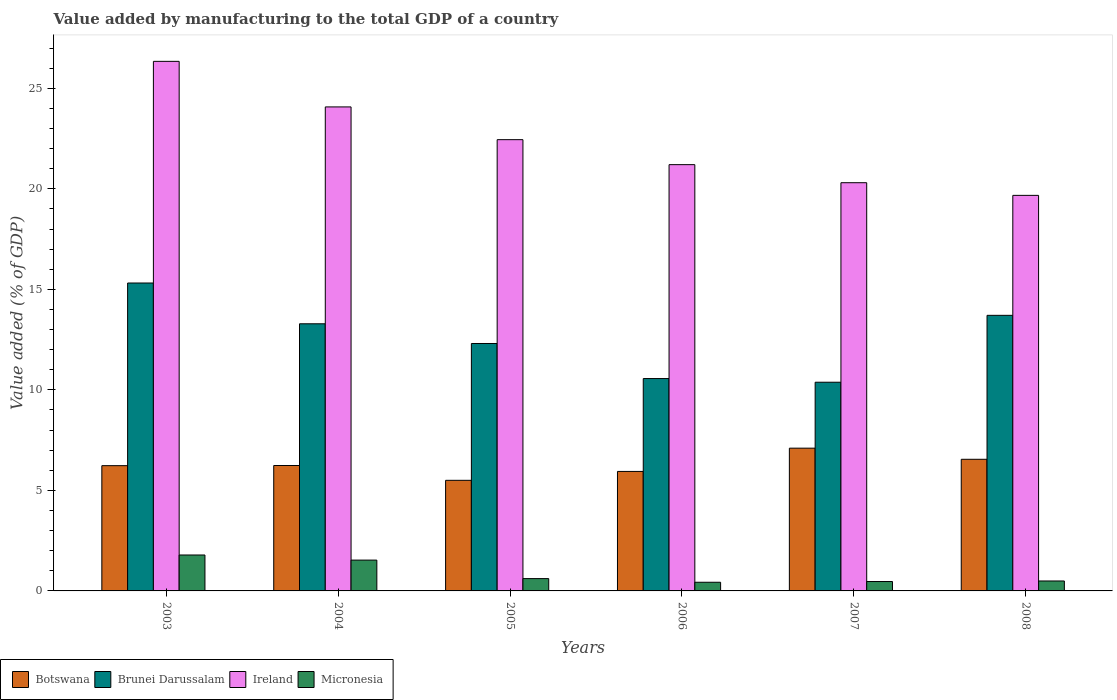How many different coloured bars are there?
Offer a very short reply. 4. What is the value added by manufacturing to the total GDP in Micronesia in 2007?
Your response must be concise. 0.47. Across all years, what is the maximum value added by manufacturing to the total GDP in Ireland?
Provide a short and direct response. 26.34. Across all years, what is the minimum value added by manufacturing to the total GDP in Ireland?
Provide a succinct answer. 19.68. In which year was the value added by manufacturing to the total GDP in Botswana maximum?
Offer a terse response. 2007. What is the total value added by manufacturing to the total GDP in Micronesia in the graph?
Offer a very short reply. 5.33. What is the difference between the value added by manufacturing to the total GDP in Brunei Darussalam in 2003 and that in 2004?
Ensure brevity in your answer.  2.03. What is the difference between the value added by manufacturing to the total GDP in Ireland in 2008 and the value added by manufacturing to the total GDP in Micronesia in 2003?
Your answer should be very brief. 17.89. What is the average value added by manufacturing to the total GDP in Botswana per year?
Provide a succinct answer. 6.26. In the year 2008, what is the difference between the value added by manufacturing to the total GDP in Ireland and value added by manufacturing to the total GDP in Brunei Darussalam?
Make the answer very short. 5.97. What is the ratio of the value added by manufacturing to the total GDP in Brunei Darussalam in 2005 to that in 2008?
Your answer should be compact. 0.9. Is the value added by manufacturing to the total GDP in Botswana in 2005 less than that in 2008?
Keep it short and to the point. Yes. What is the difference between the highest and the second highest value added by manufacturing to the total GDP in Brunei Darussalam?
Offer a terse response. 1.61. What is the difference between the highest and the lowest value added by manufacturing to the total GDP in Brunei Darussalam?
Offer a very short reply. 4.93. Is the sum of the value added by manufacturing to the total GDP in Botswana in 2005 and 2007 greater than the maximum value added by manufacturing to the total GDP in Brunei Darussalam across all years?
Ensure brevity in your answer.  No. Is it the case that in every year, the sum of the value added by manufacturing to the total GDP in Brunei Darussalam and value added by manufacturing to the total GDP in Micronesia is greater than the sum of value added by manufacturing to the total GDP in Ireland and value added by manufacturing to the total GDP in Botswana?
Make the answer very short. No. What does the 2nd bar from the left in 2007 represents?
Offer a terse response. Brunei Darussalam. What does the 2nd bar from the right in 2005 represents?
Make the answer very short. Ireland. Is it the case that in every year, the sum of the value added by manufacturing to the total GDP in Micronesia and value added by manufacturing to the total GDP in Brunei Darussalam is greater than the value added by manufacturing to the total GDP in Ireland?
Your response must be concise. No. How many years are there in the graph?
Ensure brevity in your answer.  6. What is the difference between two consecutive major ticks on the Y-axis?
Your answer should be very brief. 5. Are the values on the major ticks of Y-axis written in scientific E-notation?
Your response must be concise. No. Does the graph contain grids?
Give a very brief answer. No. Where does the legend appear in the graph?
Offer a very short reply. Bottom left. What is the title of the graph?
Give a very brief answer. Value added by manufacturing to the total GDP of a country. What is the label or title of the Y-axis?
Keep it short and to the point. Value added (% of GDP). What is the Value added (% of GDP) in Botswana in 2003?
Give a very brief answer. 6.23. What is the Value added (% of GDP) in Brunei Darussalam in 2003?
Give a very brief answer. 15.32. What is the Value added (% of GDP) in Ireland in 2003?
Offer a very short reply. 26.34. What is the Value added (% of GDP) of Micronesia in 2003?
Ensure brevity in your answer.  1.79. What is the Value added (% of GDP) of Botswana in 2004?
Provide a succinct answer. 6.24. What is the Value added (% of GDP) in Brunei Darussalam in 2004?
Offer a very short reply. 13.29. What is the Value added (% of GDP) in Ireland in 2004?
Your response must be concise. 24.07. What is the Value added (% of GDP) of Micronesia in 2004?
Give a very brief answer. 1.53. What is the Value added (% of GDP) of Botswana in 2005?
Keep it short and to the point. 5.5. What is the Value added (% of GDP) of Brunei Darussalam in 2005?
Give a very brief answer. 12.31. What is the Value added (% of GDP) in Ireland in 2005?
Provide a succinct answer. 22.45. What is the Value added (% of GDP) of Micronesia in 2005?
Give a very brief answer. 0.61. What is the Value added (% of GDP) of Botswana in 2006?
Offer a very short reply. 5.94. What is the Value added (% of GDP) in Brunei Darussalam in 2006?
Your answer should be very brief. 10.56. What is the Value added (% of GDP) of Ireland in 2006?
Keep it short and to the point. 21.2. What is the Value added (% of GDP) of Micronesia in 2006?
Keep it short and to the point. 0.43. What is the Value added (% of GDP) of Botswana in 2007?
Provide a short and direct response. 7.1. What is the Value added (% of GDP) of Brunei Darussalam in 2007?
Offer a terse response. 10.38. What is the Value added (% of GDP) of Ireland in 2007?
Make the answer very short. 20.31. What is the Value added (% of GDP) of Micronesia in 2007?
Give a very brief answer. 0.47. What is the Value added (% of GDP) of Botswana in 2008?
Your response must be concise. 6.55. What is the Value added (% of GDP) in Brunei Darussalam in 2008?
Your response must be concise. 13.71. What is the Value added (% of GDP) of Ireland in 2008?
Ensure brevity in your answer.  19.68. What is the Value added (% of GDP) in Micronesia in 2008?
Make the answer very short. 0.49. Across all years, what is the maximum Value added (% of GDP) of Botswana?
Provide a short and direct response. 7.1. Across all years, what is the maximum Value added (% of GDP) in Brunei Darussalam?
Offer a terse response. 15.32. Across all years, what is the maximum Value added (% of GDP) of Ireland?
Your answer should be compact. 26.34. Across all years, what is the maximum Value added (% of GDP) of Micronesia?
Your answer should be compact. 1.79. Across all years, what is the minimum Value added (% of GDP) in Botswana?
Make the answer very short. 5.5. Across all years, what is the minimum Value added (% of GDP) of Brunei Darussalam?
Give a very brief answer. 10.38. Across all years, what is the minimum Value added (% of GDP) in Ireland?
Give a very brief answer. 19.68. Across all years, what is the minimum Value added (% of GDP) in Micronesia?
Ensure brevity in your answer.  0.43. What is the total Value added (% of GDP) in Botswana in the graph?
Your answer should be compact. 37.56. What is the total Value added (% of GDP) in Brunei Darussalam in the graph?
Make the answer very short. 75.56. What is the total Value added (% of GDP) of Ireland in the graph?
Your response must be concise. 134.05. What is the total Value added (% of GDP) in Micronesia in the graph?
Your answer should be very brief. 5.33. What is the difference between the Value added (% of GDP) of Botswana in 2003 and that in 2004?
Provide a short and direct response. -0.01. What is the difference between the Value added (% of GDP) of Brunei Darussalam in 2003 and that in 2004?
Your answer should be compact. 2.03. What is the difference between the Value added (% of GDP) of Ireland in 2003 and that in 2004?
Your answer should be very brief. 2.27. What is the difference between the Value added (% of GDP) in Micronesia in 2003 and that in 2004?
Provide a succinct answer. 0.25. What is the difference between the Value added (% of GDP) of Botswana in 2003 and that in 2005?
Your response must be concise. 0.73. What is the difference between the Value added (% of GDP) of Brunei Darussalam in 2003 and that in 2005?
Provide a succinct answer. 3.01. What is the difference between the Value added (% of GDP) of Ireland in 2003 and that in 2005?
Your answer should be very brief. 3.89. What is the difference between the Value added (% of GDP) of Micronesia in 2003 and that in 2005?
Give a very brief answer. 1.17. What is the difference between the Value added (% of GDP) in Botswana in 2003 and that in 2006?
Your answer should be very brief. 0.29. What is the difference between the Value added (% of GDP) in Brunei Darussalam in 2003 and that in 2006?
Ensure brevity in your answer.  4.75. What is the difference between the Value added (% of GDP) in Ireland in 2003 and that in 2006?
Provide a short and direct response. 5.14. What is the difference between the Value added (% of GDP) of Micronesia in 2003 and that in 2006?
Provide a succinct answer. 1.36. What is the difference between the Value added (% of GDP) in Botswana in 2003 and that in 2007?
Ensure brevity in your answer.  -0.87. What is the difference between the Value added (% of GDP) of Brunei Darussalam in 2003 and that in 2007?
Provide a succinct answer. 4.93. What is the difference between the Value added (% of GDP) of Ireland in 2003 and that in 2007?
Give a very brief answer. 6.04. What is the difference between the Value added (% of GDP) in Micronesia in 2003 and that in 2007?
Ensure brevity in your answer.  1.32. What is the difference between the Value added (% of GDP) in Botswana in 2003 and that in 2008?
Give a very brief answer. -0.32. What is the difference between the Value added (% of GDP) of Brunei Darussalam in 2003 and that in 2008?
Your answer should be very brief. 1.61. What is the difference between the Value added (% of GDP) of Ireland in 2003 and that in 2008?
Keep it short and to the point. 6.67. What is the difference between the Value added (% of GDP) in Micronesia in 2003 and that in 2008?
Your response must be concise. 1.29. What is the difference between the Value added (% of GDP) in Botswana in 2004 and that in 2005?
Ensure brevity in your answer.  0.74. What is the difference between the Value added (% of GDP) in Brunei Darussalam in 2004 and that in 2005?
Offer a terse response. 0.98. What is the difference between the Value added (% of GDP) of Ireland in 2004 and that in 2005?
Provide a succinct answer. 1.63. What is the difference between the Value added (% of GDP) in Micronesia in 2004 and that in 2005?
Offer a terse response. 0.92. What is the difference between the Value added (% of GDP) of Botswana in 2004 and that in 2006?
Keep it short and to the point. 0.29. What is the difference between the Value added (% of GDP) in Brunei Darussalam in 2004 and that in 2006?
Ensure brevity in your answer.  2.72. What is the difference between the Value added (% of GDP) of Ireland in 2004 and that in 2006?
Your response must be concise. 2.87. What is the difference between the Value added (% of GDP) of Micronesia in 2004 and that in 2006?
Give a very brief answer. 1.1. What is the difference between the Value added (% of GDP) of Botswana in 2004 and that in 2007?
Offer a very short reply. -0.86. What is the difference between the Value added (% of GDP) in Brunei Darussalam in 2004 and that in 2007?
Keep it short and to the point. 2.91. What is the difference between the Value added (% of GDP) of Ireland in 2004 and that in 2007?
Your answer should be very brief. 3.77. What is the difference between the Value added (% of GDP) of Micronesia in 2004 and that in 2007?
Your response must be concise. 1.07. What is the difference between the Value added (% of GDP) of Botswana in 2004 and that in 2008?
Your answer should be very brief. -0.31. What is the difference between the Value added (% of GDP) of Brunei Darussalam in 2004 and that in 2008?
Offer a terse response. -0.42. What is the difference between the Value added (% of GDP) of Ireland in 2004 and that in 2008?
Keep it short and to the point. 4.4. What is the difference between the Value added (% of GDP) in Micronesia in 2004 and that in 2008?
Your response must be concise. 1.04. What is the difference between the Value added (% of GDP) of Botswana in 2005 and that in 2006?
Give a very brief answer. -0.44. What is the difference between the Value added (% of GDP) in Brunei Darussalam in 2005 and that in 2006?
Ensure brevity in your answer.  1.74. What is the difference between the Value added (% of GDP) in Ireland in 2005 and that in 2006?
Make the answer very short. 1.24. What is the difference between the Value added (% of GDP) in Micronesia in 2005 and that in 2006?
Your answer should be compact. 0.18. What is the difference between the Value added (% of GDP) in Botswana in 2005 and that in 2007?
Provide a succinct answer. -1.6. What is the difference between the Value added (% of GDP) of Brunei Darussalam in 2005 and that in 2007?
Make the answer very short. 1.93. What is the difference between the Value added (% of GDP) in Ireland in 2005 and that in 2007?
Provide a succinct answer. 2.14. What is the difference between the Value added (% of GDP) of Micronesia in 2005 and that in 2007?
Offer a very short reply. 0.15. What is the difference between the Value added (% of GDP) of Botswana in 2005 and that in 2008?
Give a very brief answer. -1.05. What is the difference between the Value added (% of GDP) of Brunei Darussalam in 2005 and that in 2008?
Make the answer very short. -1.4. What is the difference between the Value added (% of GDP) in Ireland in 2005 and that in 2008?
Provide a succinct answer. 2.77. What is the difference between the Value added (% of GDP) in Micronesia in 2005 and that in 2008?
Ensure brevity in your answer.  0.12. What is the difference between the Value added (% of GDP) of Botswana in 2006 and that in 2007?
Make the answer very short. -1.16. What is the difference between the Value added (% of GDP) of Brunei Darussalam in 2006 and that in 2007?
Your answer should be very brief. 0.18. What is the difference between the Value added (% of GDP) in Ireland in 2006 and that in 2007?
Your answer should be very brief. 0.9. What is the difference between the Value added (% of GDP) of Micronesia in 2006 and that in 2007?
Provide a short and direct response. -0.04. What is the difference between the Value added (% of GDP) in Botswana in 2006 and that in 2008?
Provide a short and direct response. -0.6. What is the difference between the Value added (% of GDP) of Brunei Darussalam in 2006 and that in 2008?
Provide a short and direct response. -3.14. What is the difference between the Value added (% of GDP) in Ireland in 2006 and that in 2008?
Your answer should be very brief. 1.53. What is the difference between the Value added (% of GDP) in Micronesia in 2006 and that in 2008?
Provide a short and direct response. -0.06. What is the difference between the Value added (% of GDP) of Botswana in 2007 and that in 2008?
Offer a terse response. 0.55. What is the difference between the Value added (% of GDP) of Brunei Darussalam in 2007 and that in 2008?
Offer a very short reply. -3.33. What is the difference between the Value added (% of GDP) in Ireland in 2007 and that in 2008?
Provide a short and direct response. 0.63. What is the difference between the Value added (% of GDP) of Micronesia in 2007 and that in 2008?
Give a very brief answer. -0.03. What is the difference between the Value added (% of GDP) in Botswana in 2003 and the Value added (% of GDP) in Brunei Darussalam in 2004?
Your answer should be very brief. -7.06. What is the difference between the Value added (% of GDP) of Botswana in 2003 and the Value added (% of GDP) of Ireland in 2004?
Your response must be concise. -17.84. What is the difference between the Value added (% of GDP) of Botswana in 2003 and the Value added (% of GDP) of Micronesia in 2004?
Your answer should be compact. 4.7. What is the difference between the Value added (% of GDP) in Brunei Darussalam in 2003 and the Value added (% of GDP) in Ireland in 2004?
Offer a terse response. -8.76. What is the difference between the Value added (% of GDP) in Brunei Darussalam in 2003 and the Value added (% of GDP) in Micronesia in 2004?
Your answer should be compact. 13.78. What is the difference between the Value added (% of GDP) of Ireland in 2003 and the Value added (% of GDP) of Micronesia in 2004?
Provide a short and direct response. 24.81. What is the difference between the Value added (% of GDP) of Botswana in 2003 and the Value added (% of GDP) of Brunei Darussalam in 2005?
Make the answer very short. -6.08. What is the difference between the Value added (% of GDP) of Botswana in 2003 and the Value added (% of GDP) of Ireland in 2005?
Give a very brief answer. -16.22. What is the difference between the Value added (% of GDP) of Botswana in 2003 and the Value added (% of GDP) of Micronesia in 2005?
Your answer should be compact. 5.62. What is the difference between the Value added (% of GDP) of Brunei Darussalam in 2003 and the Value added (% of GDP) of Ireland in 2005?
Keep it short and to the point. -7.13. What is the difference between the Value added (% of GDP) of Brunei Darussalam in 2003 and the Value added (% of GDP) of Micronesia in 2005?
Provide a succinct answer. 14.7. What is the difference between the Value added (% of GDP) in Ireland in 2003 and the Value added (% of GDP) in Micronesia in 2005?
Your response must be concise. 25.73. What is the difference between the Value added (% of GDP) of Botswana in 2003 and the Value added (% of GDP) of Brunei Darussalam in 2006?
Offer a terse response. -4.33. What is the difference between the Value added (% of GDP) in Botswana in 2003 and the Value added (% of GDP) in Ireland in 2006?
Offer a terse response. -14.97. What is the difference between the Value added (% of GDP) of Botswana in 2003 and the Value added (% of GDP) of Micronesia in 2006?
Give a very brief answer. 5.8. What is the difference between the Value added (% of GDP) of Brunei Darussalam in 2003 and the Value added (% of GDP) of Ireland in 2006?
Your response must be concise. -5.89. What is the difference between the Value added (% of GDP) of Brunei Darussalam in 2003 and the Value added (% of GDP) of Micronesia in 2006?
Offer a terse response. 14.88. What is the difference between the Value added (% of GDP) in Ireland in 2003 and the Value added (% of GDP) in Micronesia in 2006?
Keep it short and to the point. 25.91. What is the difference between the Value added (% of GDP) in Botswana in 2003 and the Value added (% of GDP) in Brunei Darussalam in 2007?
Make the answer very short. -4.15. What is the difference between the Value added (% of GDP) in Botswana in 2003 and the Value added (% of GDP) in Ireland in 2007?
Your answer should be very brief. -14.07. What is the difference between the Value added (% of GDP) of Botswana in 2003 and the Value added (% of GDP) of Micronesia in 2007?
Your response must be concise. 5.76. What is the difference between the Value added (% of GDP) of Brunei Darussalam in 2003 and the Value added (% of GDP) of Ireland in 2007?
Your answer should be compact. -4.99. What is the difference between the Value added (% of GDP) in Brunei Darussalam in 2003 and the Value added (% of GDP) in Micronesia in 2007?
Make the answer very short. 14.85. What is the difference between the Value added (% of GDP) of Ireland in 2003 and the Value added (% of GDP) of Micronesia in 2007?
Your answer should be compact. 25.87. What is the difference between the Value added (% of GDP) in Botswana in 2003 and the Value added (% of GDP) in Brunei Darussalam in 2008?
Provide a succinct answer. -7.48. What is the difference between the Value added (% of GDP) of Botswana in 2003 and the Value added (% of GDP) of Ireland in 2008?
Keep it short and to the point. -13.44. What is the difference between the Value added (% of GDP) in Botswana in 2003 and the Value added (% of GDP) in Micronesia in 2008?
Offer a terse response. 5.74. What is the difference between the Value added (% of GDP) of Brunei Darussalam in 2003 and the Value added (% of GDP) of Ireland in 2008?
Offer a terse response. -4.36. What is the difference between the Value added (% of GDP) of Brunei Darussalam in 2003 and the Value added (% of GDP) of Micronesia in 2008?
Provide a succinct answer. 14.82. What is the difference between the Value added (% of GDP) of Ireland in 2003 and the Value added (% of GDP) of Micronesia in 2008?
Your response must be concise. 25.85. What is the difference between the Value added (% of GDP) of Botswana in 2004 and the Value added (% of GDP) of Brunei Darussalam in 2005?
Keep it short and to the point. -6.07. What is the difference between the Value added (% of GDP) in Botswana in 2004 and the Value added (% of GDP) in Ireland in 2005?
Offer a very short reply. -16.21. What is the difference between the Value added (% of GDP) of Botswana in 2004 and the Value added (% of GDP) of Micronesia in 2005?
Provide a short and direct response. 5.63. What is the difference between the Value added (% of GDP) in Brunei Darussalam in 2004 and the Value added (% of GDP) in Ireland in 2005?
Your answer should be compact. -9.16. What is the difference between the Value added (% of GDP) in Brunei Darussalam in 2004 and the Value added (% of GDP) in Micronesia in 2005?
Make the answer very short. 12.67. What is the difference between the Value added (% of GDP) in Ireland in 2004 and the Value added (% of GDP) in Micronesia in 2005?
Offer a very short reply. 23.46. What is the difference between the Value added (% of GDP) in Botswana in 2004 and the Value added (% of GDP) in Brunei Darussalam in 2006?
Offer a very short reply. -4.33. What is the difference between the Value added (% of GDP) of Botswana in 2004 and the Value added (% of GDP) of Ireland in 2006?
Offer a terse response. -14.96. What is the difference between the Value added (% of GDP) in Botswana in 2004 and the Value added (% of GDP) in Micronesia in 2006?
Your response must be concise. 5.81. What is the difference between the Value added (% of GDP) of Brunei Darussalam in 2004 and the Value added (% of GDP) of Ireland in 2006?
Make the answer very short. -7.92. What is the difference between the Value added (% of GDP) of Brunei Darussalam in 2004 and the Value added (% of GDP) of Micronesia in 2006?
Ensure brevity in your answer.  12.86. What is the difference between the Value added (% of GDP) of Ireland in 2004 and the Value added (% of GDP) of Micronesia in 2006?
Provide a short and direct response. 23.64. What is the difference between the Value added (% of GDP) in Botswana in 2004 and the Value added (% of GDP) in Brunei Darussalam in 2007?
Provide a succinct answer. -4.14. What is the difference between the Value added (% of GDP) of Botswana in 2004 and the Value added (% of GDP) of Ireland in 2007?
Your response must be concise. -14.07. What is the difference between the Value added (% of GDP) of Botswana in 2004 and the Value added (% of GDP) of Micronesia in 2007?
Offer a very short reply. 5.77. What is the difference between the Value added (% of GDP) of Brunei Darussalam in 2004 and the Value added (% of GDP) of Ireland in 2007?
Offer a terse response. -7.02. What is the difference between the Value added (% of GDP) of Brunei Darussalam in 2004 and the Value added (% of GDP) of Micronesia in 2007?
Ensure brevity in your answer.  12.82. What is the difference between the Value added (% of GDP) in Ireland in 2004 and the Value added (% of GDP) in Micronesia in 2007?
Ensure brevity in your answer.  23.61. What is the difference between the Value added (% of GDP) of Botswana in 2004 and the Value added (% of GDP) of Brunei Darussalam in 2008?
Ensure brevity in your answer.  -7.47. What is the difference between the Value added (% of GDP) of Botswana in 2004 and the Value added (% of GDP) of Ireland in 2008?
Offer a very short reply. -13.44. What is the difference between the Value added (% of GDP) in Botswana in 2004 and the Value added (% of GDP) in Micronesia in 2008?
Keep it short and to the point. 5.74. What is the difference between the Value added (% of GDP) of Brunei Darussalam in 2004 and the Value added (% of GDP) of Ireland in 2008?
Offer a terse response. -6.39. What is the difference between the Value added (% of GDP) in Brunei Darussalam in 2004 and the Value added (% of GDP) in Micronesia in 2008?
Give a very brief answer. 12.79. What is the difference between the Value added (% of GDP) of Ireland in 2004 and the Value added (% of GDP) of Micronesia in 2008?
Make the answer very short. 23.58. What is the difference between the Value added (% of GDP) in Botswana in 2005 and the Value added (% of GDP) in Brunei Darussalam in 2006?
Your answer should be compact. -5.06. What is the difference between the Value added (% of GDP) in Botswana in 2005 and the Value added (% of GDP) in Ireland in 2006?
Ensure brevity in your answer.  -15.7. What is the difference between the Value added (% of GDP) in Botswana in 2005 and the Value added (% of GDP) in Micronesia in 2006?
Give a very brief answer. 5.07. What is the difference between the Value added (% of GDP) in Brunei Darussalam in 2005 and the Value added (% of GDP) in Ireland in 2006?
Offer a terse response. -8.9. What is the difference between the Value added (% of GDP) in Brunei Darussalam in 2005 and the Value added (% of GDP) in Micronesia in 2006?
Ensure brevity in your answer.  11.88. What is the difference between the Value added (% of GDP) in Ireland in 2005 and the Value added (% of GDP) in Micronesia in 2006?
Offer a terse response. 22.02. What is the difference between the Value added (% of GDP) of Botswana in 2005 and the Value added (% of GDP) of Brunei Darussalam in 2007?
Provide a short and direct response. -4.88. What is the difference between the Value added (% of GDP) in Botswana in 2005 and the Value added (% of GDP) in Ireland in 2007?
Your response must be concise. -14.8. What is the difference between the Value added (% of GDP) in Botswana in 2005 and the Value added (% of GDP) in Micronesia in 2007?
Make the answer very short. 5.03. What is the difference between the Value added (% of GDP) of Brunei Darussalam in 2005 and the Value added (% of GDP) of Ireland in 2007?
Give a very brief answer. -8. What is the difference between the Value added (% of GDP) in Brunei Darussalam in 2005 and the Value added (% of GDP) in Micronesia in 2007?
Offer a terse response. 11.84. What is the difference between the Value added (% of GDP) in Ireland in 2005 and the Value added (% of GDP) in Micronesia in 2007?
Your answer should be compact. 21.98. What is the difference between the Value added (% of GDP) in Botswana in 2005 and the Value added (% of GDP) in Brunei Darussalam in 2008?
Offer a very short reply. -8.21. What is the difference between the Value added (% of GDP) in Botswana in 2005 and the Value added (% of GDP) in Ireland in 2008?
Your answer should be compact. -14.17. What is the difference between the Value added (% of GDP) in Botswana in 2005 and the Value added (% of GDP) in Micronesia in 2008?
Make the answer very short. 5.01. What is the difference between the Value added (% of GDP) of Brunei Darussalam in 2005 and the Value added (% of GDP) of Ireland in 2008?
Keep it short and to the point. -7.37. What is the difference between the Value added (% of GDP) of Brunei Darussalam in 2005 and the Value added (% of GDP) of Micronesia in 2008?
Offer a terse response. 11.81. What is the difference between the Value added (% of GDP) in Ireland in 2005 and the Value added (% of GDP) in Micronesia in 2008?
Give a very brief answer. 21.95. What is the difference between the Value added (% of GDP) in Botswana in 2006 and the Value added (% of GDP) in Brunei Darussalam in 2007?
Make the answer very short. -4.44. What is the difference between the Value added (% of GDP) in Botswana in 2006 and the Value added (% of GDP) in Ireland in 2007?
Provide a short and direct response. -14.36. What is the difference between the Value added (% of GDP) of Botswana in 2006 and the Value added (% of GDP) of Micronesia in 2007?
Provide a short and direct response. 5.48. What is the difference between the Value added (% of GDP) in Brunei Darussalam in 2006 and the Value added (% of GDP) in Ireland in 2007?
Give a very brief answer. -9.74. What is the difference between the Value added (% of GDP) in Brunei Darussalam in 2006 and the Value added (% of GDP) in Micronesia in 2007?
Offer a terse response. 10.1. What is the difference between the Value added (% of GDP) of Ireland in 2006 and the Value added (% of GDP) of Micronesia in 2007?
Offer a terse response. 20.74. What is the difference between the Value added (% of GDP) in Botswana in 2006 and the Value added (% of GDP) in Brunei Darussalam in 2008?
Your answer should be very brief. -7.76. What is the difference between the Value added (% of GDP) of Botswana in 2006 and the Value added (% of GDP) of Ireland in 2008?
Make the answer very short. -13.73. What is the difference between the Value added (% of GDP) of Botswana in 2006 and the Value added (% of GDP) of Micronesia in 2008?
Provide a short and direct response. 5.45. What is the difference between the Value added (% of GDP) of Brunei Darussalam in 2006 and the Value added (% of GDP) of Ireland in 2008?
Give a very brief answer. -9.11. What is the difference between the Value added (% of GDP) in Brunei Darussalam in 2006 and the Value added (% of GDP) in Micronesia in 2008?
Give a very brief answer. 10.07. What is the difference between the Value added (% of GDP) in Ireland in 2006 and the Value added (% of GDP) in Micronesia in 2008?
Make the answer very short. 20.71. What is the difference between the Value added (% of GDP) in Botswana in 2007 and the Value added (% of GDP) in Brunei Darussalam in 2008?
Give a very brief answer. -6.61. What is the difference between the Value added (% of GDP) in Botswana in 2007 and the Value added (% of GDP) in Ireland in 2008?
Provide a short and direct response. -12.57. What is the difference between the Value added (% of GDP) of Botswana in 2007 and the Value added (% of GDP) of Micronesia in 2008?
Your answer should be very brief. 6.61. What is the difference between the Value added (% of GDP) in Brunei Darussalam in 2007 and the Value added (% of GDP) in Ireland in 2008?
Your answer should be compact. -9.29. What is the difference between the Value added (% of GDP) in Brunei Darussalam in 2007 and the Value added (% of GDP) in Micronesia in 2008?
Ensure brevity in your answer.  9.89. What is the difference between the Value added (% of GDP) of Ireland in 2007 and the Value added (% of GDP) of Micronesia in 2008?
Offer a very short reply. 19.81. What is the average Value added (% of GDP) of Botswana per year?
Your answer should be compact. 6.26. What is the average Value added (% of GDP) in Brunei Darussalam per year?
Provide a short and direct response. 12.59. What is the average Value added (% of GDP) in Ireland per year?
Keep it short and to the point. 22.34. What is the average Value added (% of GDP) of Micronesia per year?
Offer a very short reply. 0.89. In the year 2003, what is the difference between the Value added (% of GDP) in Botswana and Value added (% of GDP) in Brunei Darussalam?
Your answer should be compact. -9.09. In the year 2003, what is the difference between the Value added (% of GDP) of Botswana and Value added (% of GDP) of Ireland?
Your answer should be compact. -20.11. In the year 2003, what is the difference between the Value added (% of GDP) in Botswana and Value added (% of GDP) in Micronesia?
Make the answer very short. 4.44. In the year 2003, what is the difference between the Value added (% of GDP) of Brunei Darussalam and Value added (% of GDP) of Ireland?
Your answer should be compact. -11.03. In the year 2003, what is the difference between the Value added (% of GDP) in Brunei Darussalam and Value added (% of GDP) in Micronesia?
Keep it short and to the point. 13.53. In the year 2003, what is the difference between the Value added (% of GDP) in Ireland and Value added (% of GDP) in Micronesia?
Offer a very short reply. 24.55. In the year 2004, what is the difference between the Value added (% of GDP) in Botswana and Value added (% of GDP) in Brunei Darussalam?
Offer a very short reply. -7.05. In the year 2004, what is the difference between the Value added (% of GDP) in Botswana and Value added (% of GDP) in Ireland?
Offer a terse response. -17.84. In the year 2004, what is the difference between the Value added (% of GDP) of Botswana and Value added (% of GDP) of Micronesia?
Ensure brevity in your answer.  4.71. In the year 2004, what is the difference between the Value added (% of GDP) of Brunei Darussalam and Value added (% of GDP) of Ireland?
Give a very brief answer. -10.79. In the year 2004, what is the difference between the Value added (% of GDP) of Brunei Darussalam and Value added (% of GDP) of Micronesia?
Your answer should be very brief. 11.75. In the year 2004, what is the difference between the Value added (% of GDP) of Ireland and Value added (% of GDP) of Micronesia?
Keep it short and to the point. 22.54. In the year 2005, what is the difference between the Value added (% of GDP) of Botswana and Value added (% of GDP) of Brunei Darussalam?
Provide a short and direct response. -6.81. In the year 2005, what is the difference between the Value added (% of GDP) of Botswana and Value added (% of GDP) of Ireland?
Your answer should be very brief. -16.95. In the year 2005, what is the difference between the Value added (% of GDP) of Botswana and Value added (% of GDP) of Micronesia?
Your answer should be very brief. 4.89. In the year 2005, what is the difference between the Value added (% of GDP) in Brunei Darussalam and Value added (% of GDP) in Ireland?
Your answer should be very brief. -10.14. In the year 2005, what is the difference between the Value added (% of GDP) of Brunei Darussalam and Value added (% of GDP) of Micronesia?
Give a very brief answer. 11.69. In the year 2005, what is the difference between the Value added (% of GDP) in Ireland and Value added (% of GDP) in Micronesia?
Your answer should be compact. 21.83. In the year 2006, what is the difference between the Value added (% of GDP) in Botswana and Value added (% of GDP) in Brunei Darussalam?
Provide a short and direct response. -4.62. In the year 2006, what is the difference between the Value added (% of GDP) in Botswana and Value added (% of GDP) in Ireland?
Offer a terse response. -15.26. In the year 2006, what is the difference between the Value added (% of GDP) in Botswana and Value added (% of GDP) in Micronesia?
Provide a short and direct response. 5.51. In the year 2006, what is the difference between the Value added (% of GDP) of Brunei Darussalam and Value added (% of GDP) of Ireland?
Your answer should be very brief. -10.64. In the year 2006, what is the difference between the Value added (% of GDP) of Brunei Darussalam and Value added (% of GDP) of Micronesia?
Offer a terse response. 10.13. In the year 2006, what is the difference between the Value added (% of GDP) in Ireland and Value added (% of GDP) in Micronesia?
Ensure brevity in your answer.  20.77. In the year 2007, what is the difference between the Value added (% of GDP) in Botswana and Value added (% of GDP) in Brunei Darussalam?
Give a very brief answer. -3.28. In the year 2007, what is the difference between the Value added (% of GDP) in Botswana and Value added (% of GDP) in Ireland?
Give a very brief answer. -13.2. In the year 2007, what is the difference between the Value added (% of GDP) in Botswana and Value added (% of GDP) in Micronesia?
Provide a succinct answer. 6.63. In the year 2007, what is the difference between the Value added (% of GDP) in Brunei Darussalam and Value added (% of GDP) in Ireland?
Provide a short and direct response. -9.92. In the year 2007, what is the difference between the Value added (% of GDP) in Brunei Darussalam and Value added (% of GDP) in Micronesia?
Offer a very short reply. 9.91. In the year 2007, what is the difference between the Value added (% of GDP) of Ireland and Value added (% of GDP) of Micronesia?
Your response must be concise. 19.84. In the year 2008, what is the difference between the Value added (% of GDP) in Botswana and Value added (% of GDP) in Brunei Darussalam?
Your response must be concise. -7.16. In the year 2008, what is the difference between the Value added (% of GDP) of Botswana and Value added (% of GDP) of Ireland?
Offer a terse response. -13.13. In the year 2008, what is the difference between the Value added (% of GDP) in Botswana and Value added (% of GDP) in Micronesia?
Give a very brief answer. 6.05. In the year 2008, what is the difference between the Value added (% of GDP) in Brunei Darussalam and Value added (% of GDP) in Ireland?
Your answer should be very brief. -5.97. In the year 2008, what is the difference between the Value added (% of GDP) in Brunei Darussalam and Value added (% of GDP) in Micronesia?
Give a very brief answer. 13.21. In the year 2008, what is the difference between the Value added (% of GDP) in Ireland and Value added (% of GDP) in Micronesia?
Your answer should be compact. 19.18. What is the ratio of the Value added (% of GDP) of Brunei Darussalam in 2003 to that in 2004?
Offer a very short reply. 1.15. What is the ratio of the Value added (% of GDP) of Ireland in 2003 to that in 2004?
Offer a very short reply. 1.09. What is the ratio of the Value added (% of GDP) in Micronesia in 2003 to that in 2004?
Offer a terse response. 1.17. What is the ratio of the Value added (% of GDP) of Botswana in 2003 to that in 2005?
Your answer should be compact. 1.13. What is the ratio of the Value added (% of GDP) in Brunei Darussalam in 2003 to that in 2005?
Keep it short and to the point. 1.24. What is the ratio of the Value added (% of GDP) of Ireland in 2003 to that in 2005?
Ensure brevity in your answer.  1.17. What is the ratio of the Value added (% of GDP) in Micronesia in 2003 to that in 2005?
Your answer should be compact. 2.92. What is the ratio of the Value added (% of GDP) of Botswana in 2003 to that in 2006?
Provide a short and direct response. 1.05. What is the ratio of the Value added (% of GDP) in Brunei Darussalam in 2003 to that in 2006?
Your response must be concise. 1.45. What is the ratio of the Value added (% of GDP) in Ireland in 2003 to that in 2006?
Your answer should be compact. 1.24. What is the ratio of the Value added (% of GDP) of Micronesia in 2003 to that in 2006?
Give a very brief answer. 4.14. What is the ratio of the Value added (% of GDP) of Botswana in 2003 to that in 2007?
Your answer should be very brief. 0.88. What is the ratio of the Value added (% of GDP) of Brunei Darussalam in 2003 to that in 2007?
Your answer should be compact. 1.48. What is the ratio of the Value added (% of GDP) of Ireland in 2003 to that in 2007?
Keep it short and to the point. 1.3. What is the ratio of the Value added (% of GDP) in Micronesia in 2003 to that in 2007?
Ensure brevity in your answer.  3.83. What is the ratio of the Value added (% of GDP) of Botswana in 2003 to that in 2008?
Offer a terse response. 0.95. What is the ratio of the Value added (% of GDP) in Brunei Darussalam in 2003 to that in 2008?
Offer a very short reply. 1.12. What is the ratio of the Value added (% of GDP) in Ireland in 2003 to that in 2008?
Your answer should be compact. 1.34. What is the ratio of the Value added (% of GDP) of Micronesia in 2003 to that in 2008?
Provide a succinct answer. 3.61. What is the ratio of the Value added (% of GDP) of Botswana in 2004 to that in 2005?
Provide a short and direct response. 1.13. What is the ratio of the Value added (% of GDP) of Brunei Darussalam in 2004 to that in 2005?
Give a very brief answer. 1.08. What is the ratio of the Value added (% of GDP) of Ireland in 2004 to that in 2005?
Your answer should be compact. 1.07. What is the ratio of the Value added (% of GDP) in Micronesia in 2004 to that in 2005?
Provide a succinct answer. 2.5. What is the ratio of the Value added (% of GDP) of Botswana in 2004 to that in 2006?
Make the answer very short. 1.05. What is the ratio of the Value added (% of GDP) of Brunei Darussalam in 2004 to that in 2006?
Keep it short and to the point. 1.26. What is the ratio of the Value added (% of GDP) in Ireland in 2004 to that in 2006?
Your answer should be very brief. 1.14. What is the ratio of the Value added (% of GDP) in Micronesia in 2004 to that in 2006?
Offer a terse response. 3.55. What is the ratio of the Value added (% of GDP) in Botswana in 2004 to that in 2007?
Your answer should be compact. 0.88. What is the ratio of the Value added (% of GDP) of Brunei Darussalam in 2004 to that in 2007?
Offer a very short reply. 1.28. What is the ratio of the Value added (% of GDP) in Ireland in 2004 to that in 2007?
Your answer should be very brief. 1.19. What is the ratio of the Value added (% of GDP) of Micronesia in 2004 to that in 2007?
Provide a short and direct response. 3.28. What is the ratio of the Value added (% of GDP) in Botswana in 2004 to that in 2008?
Ensure brevity in your answer.  0.95. What is the ratio of the Value added (% of GDP) in Brunei Darussalam in 2004 to that in 2008?
Your answer should be very brief. 0.97. What is the ratio of the Value added (% of GDP) in Ireland in 2004 to that in 2008?
Offer a terse response. 1.22. What is the ratio of the Value added (% of GDP) of Micronesia in 2004 to that in 2008?
Ensure brevity in your answer.  3.1. What is the ratio of the Value added (% of GDP) of Botswana in 2005 to that in 2006?
Offer a very short reply. 0.93. What is the ratio of the Value added (% of GDP) in Brunei Darussalam in 2005 to that in 2006?
Keep it short and to the point. 1.17. What is the ratio of the Value added (% of GDP) of Ireland in 2005 to that in 2006?
Offer a very short reply. 1.06. What is the ratio of the Value added (% of GDP) in Micronesia in 2005 to that in 2006?
Give a very brief answer. 1.42. What is the ratio of the Value added (% of GDP) in Botswana in 2005 to that in 2007?
Provide a short and direct response. 0.77. What is the ratio of the Value added (% of GDP) of Brunei Darussalam in 2005 to that in 2007?
Make the answer very short. 1.19. What is the ratio of the Value added (% of GDP) of Ireland in 2005 to that in 2007?
Make the answer very short. 1.11. What is the ratio of the Value added (% of GDP) of Micronesia in 2005 to that in 2007?
Provide a succinct answer. 1.31. What is the ratio of the Value added (% of GDP) in Botswana in 2005 to that in 2008?
Keep it short and to the point. 0.84. What is the ratio of the Value added (% of GDP) of Brunei Darussalam in 2005 to that in 2008?
Offer a very short reply. 0.9. What is the ratio of the Value added (% of GDP) of Ireland in 2005 to that in 2008?
Keep it short and to the point. 1.14. What is the ratio of the Value added (% of GDP) of Micronesia in 2005 to that in 2008?
Give a very brief answer. 1.24. What is the ratio of the Value added (% of GDP) of Botswana in 2006 to that in 2007?
Your response must be concise. 0.84. What is the ratio of the Value added (% of GDP) in Brunei Darussalam in 2006 to that in 2007?
Keep it short and to the point. 1.02. What is the ratio of the Value added (% of GDP) of Ireland in 2006 to that in 2007?
Give a very brief answer. 1.04. What is the ratio of the Value added (% of GDP) in Micronesia in 2006 to that in 2007?
Offer a very short reply. 0.92. What is the ratio of the Value added (% of GDP) of Botswana in 2006 to that in 2008?
Give a very brief answer. 0.91. What is the ratio of the Value added (% of GDP) in Brunei Darussalam in 2006 to that in 2008?
Offer a terse response. 0.77. What is the ratio of the Value added (% of GDP) of Ireland in 2006 to that in 2008?
Your response must be concise. 1.08. What is the ratio of the Value added (% of GDP) in Micronesia in 2006 to that in 2008?
Your answer should be compact. 0.87. What is the ratio of the Value added (% of GDP) of Botswana in 2007 to that in 2008?
Provide a succinct answer. 1.08. What is the ratio of the Value added (% of GDP) in Brunei Darussalam in 2007 to that in 2008?
Ensure brevity in your answer.  0.76. What is the ratio of the Value added (% of GDP) in Ireland in 2007 to that in 2008?
Offer a terse response. 1.03. What is the ratio of the Value added (% of GDP) in Micronesia in 2007 to that in 2008?
Give a very brief answer. 0.94. What is the difference between the highest and the second highest Value added (% of GDP) in Botswana?
Keep it short and to the point. 0.55. What is the difference between the highest and the second highest Value added (% of GDP) in Brunei Darussalam?
Offer a terse response. 1.61. What is the difference between the highest and the second highest Value added (% of GDP) in Ireland?
Provide a succinct answer. 2.27. What is the difference between the highest and the second highest Value added (% of GDP) of Micronesia?
Your answer should be compact. 0.25. What is the difference between the highest and the lowest Value added (% of GDP) of Botswana?
Keep it short and to the point. 1.6. What is the difference between the highest and the lowest Value added (% of GDP) in Brunei Darussalam?
Keep it short and to the point. 4.93. What is the difference between the highest and the lowest Value added (% of GDP) of Ireland?
Offer a very short reply. 6.67. What is the difference between the highest and the lowest Value added (% of GDP) of Micronesia?
Your answer should be very brief. 1.36. 